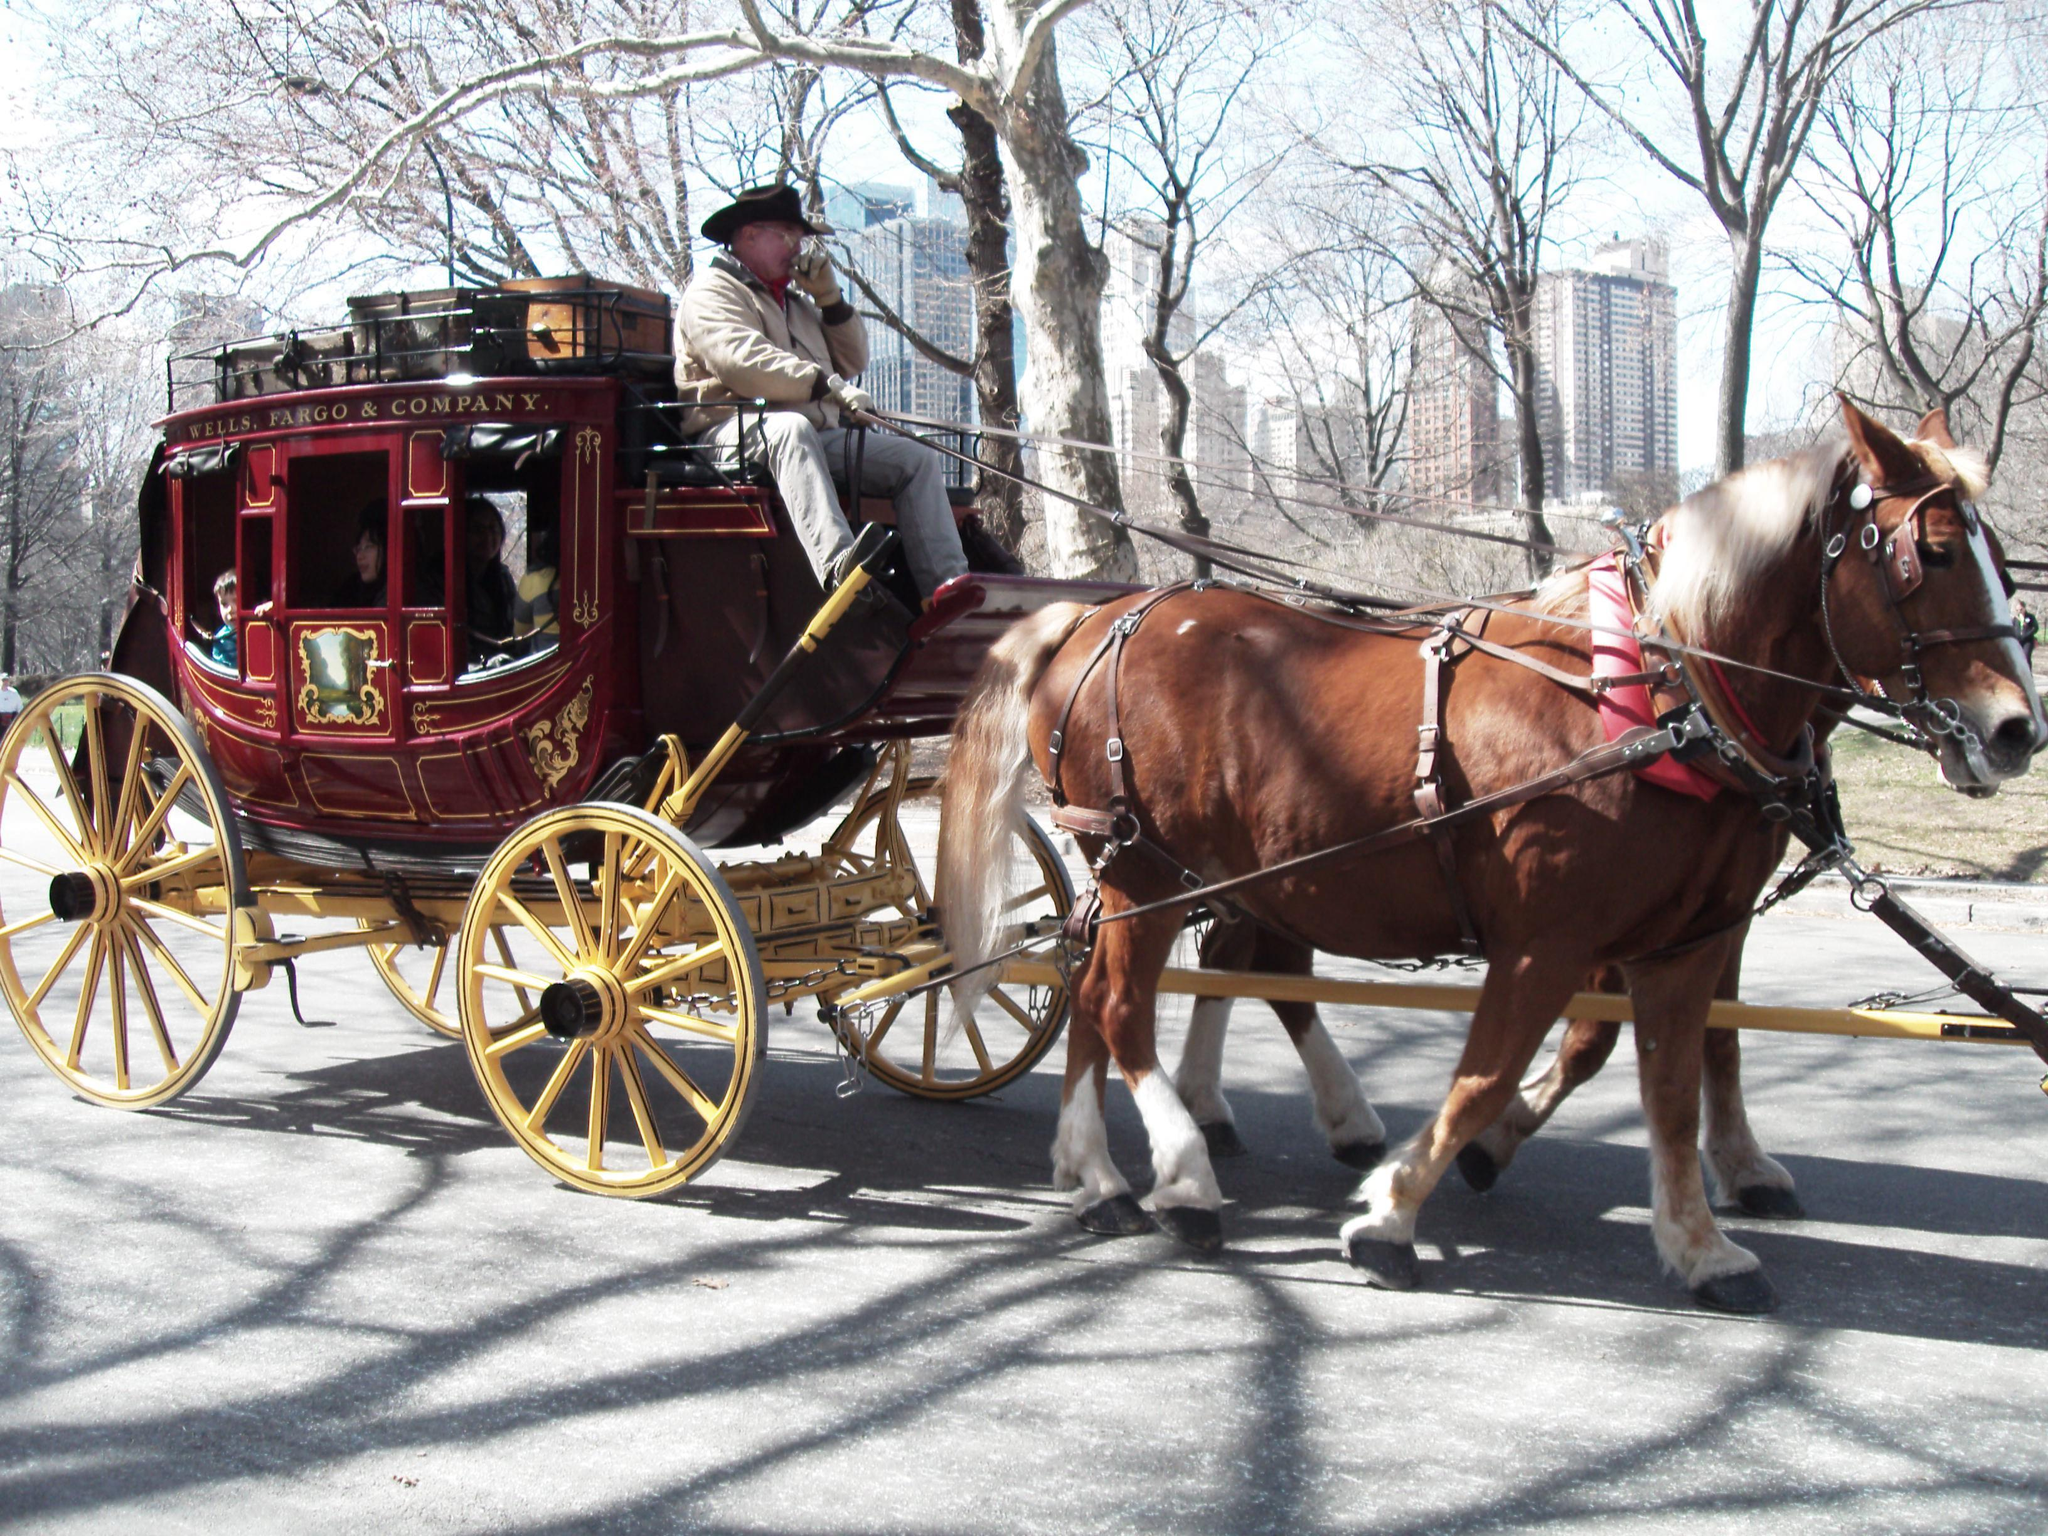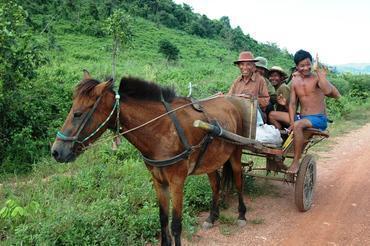The first image is the image on the left, the second image is the image on the right. For the images displayed, is the sentence "The wagon in the image on the right is not attached to a horse." factually correct? Answer yes or no. No. The first image is the image on the left, the second image is the image on the right. For the images displayed, is the sentence "An image shows two side-by-side horses pulling some type of wheeled thing steered by a man." factually correct? Answer yes or no. Yes. 